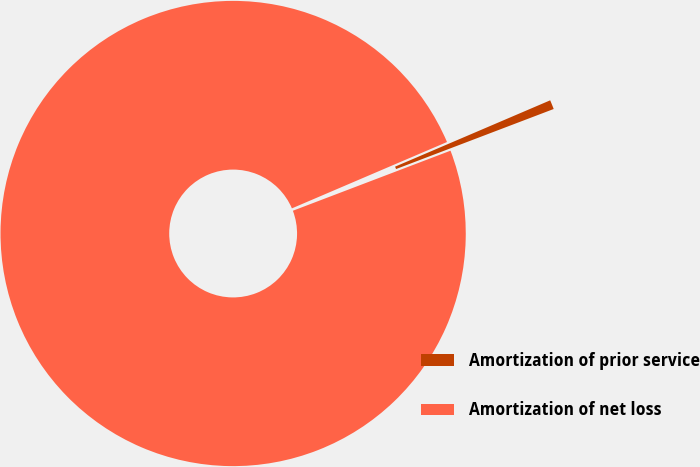Convert chart to OTSL. <chart><loc_0><loc_0><loc_500><loc_500><pie_chart><fcel>Amortization of prior service<fcel>Amortization of net loss<nl><fcel>0.64%<fcel>99.36%<nl></chart> 